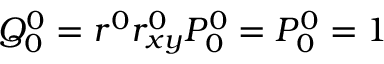Convert formula to latex. <formula><loc_0><loc_0><loc_500><loc_500>Q _ { 0 } ^ { 0 } = r ^ { 0 } r _ { x y } ^ { 0 } P _ { 0 } ^ { 0 } = P _ { 0 } ^ { 0 } = 1</formula> 